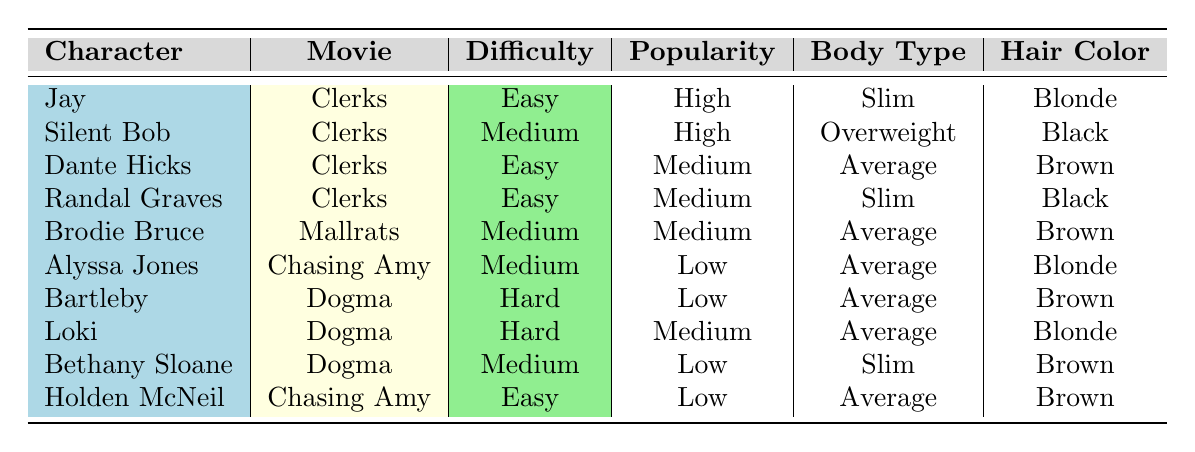What character from Clerks has high popularity and an easy difficulty level? Checking the table, "Jay" is listed under the movie "Clerks" with both high popularity and easy difficulty.
Answer: Jay Which character is considered hard to cosplay and has low popularity? The only character with hard difficulty and low popularity is "Bartleby."
Answer: Bartleby How many characters have an average body type? Counting from the table, there are three characters with average body type: "Dante Hicks," "Brodie Bruce," and "Alyssa Jones."
Answer: Three Is there any character with the name "Bethany Sloane"? The table shows that "Bethany Sloane" is indeed present.
Answer: Yes Which character from Dogma has a slim body type? Looking at the table, "Bethany Sloane" is noted to have a slim body type among the characters from "Dogma."
Answer: Bethany Sloane How many characters are marked as easy difficulty? Referring to the table, the characters marked as easy difficulty are "Jay," "Dante Hicks," "Randal Graves," and "Holden McNeil," totaling four characters.
Answer: Four Which hair color is most common among the characters? Reviewing the table, "Brown" appears five times among various characters. Hence, it is the most common hair color.
Answer: Brown If I want a character that is high in popularity and has brown hair, which character should I choose? Filtering the table, "Dante Hicks" is the only character with brown hair and medium popularity; however, there are no characters that match both high popularity and brown hair.
Answer: None Which character requires the least skill in prop-making according to the table? The character "Jay" is listed with easy difficulty and high popularity, implying less skill in prop-making is needed compared to others who may be harder.
Answer: Jay 